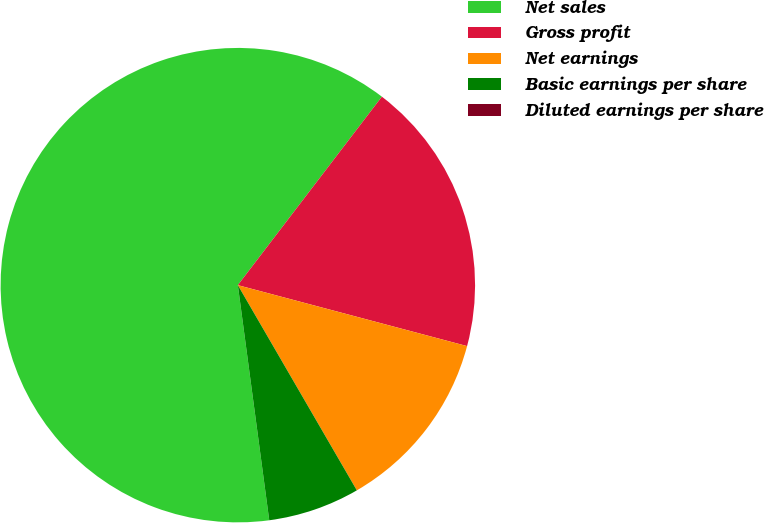Convert chart to OTSL. <chart><loc_0><loc_0><loc_500><loc_500><pie_chart><fcel>Net sales<fcel>Gross profit<fcel>Net earnings<fcel>Basic earnings per share<fcel>Diluted earnings per share<nl><fcel>62.5%<fcel>18.75%<fcel>12.5%<fcel>6.25%<fcel>0.0%<nl></chart> 